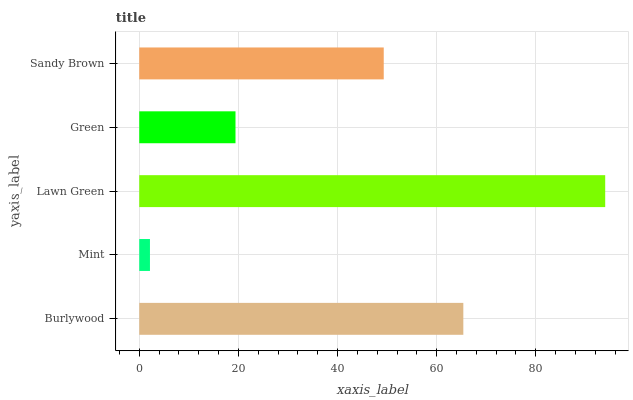Is Mint the minimum?
Answer yes or no. Yes. Is Lawn Green the maximum?
Answer yes or no. Yes. Is Lawn Green the minimum?
Answer yes or no. No. Is Mint the maximum?
Answer yes or no. No. Is Lawn Green greater than Mint?
Answer yes or no. Yes. Is Mint less than Lawn Green?
Answer yes or no. Yes. Is Mint greater than Lawn Green?
Answer yes or no. No. Is Lawn Green less than Mint?
Answer yes or no. No. Is Sandy Brown the high median?
Answer yes or no. Yes. Is Sandy Brown the low median?
Answer yes or no. Yes. Is Lawn Green the high median?
Answer yes or no. No. Is Mint the low median?
Answer yes or no. No. 